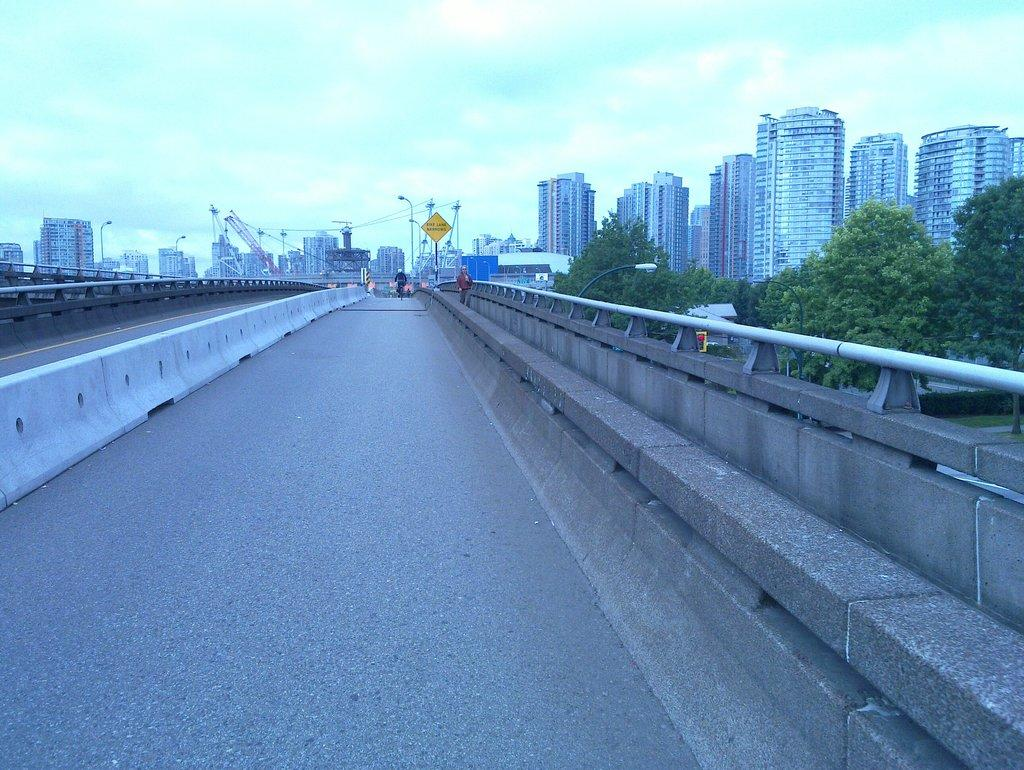What is the main feature of the image? The image contains a road. What can be seen on the right side of the image? There are trees and buildings on the right side of the image. What type of pollution can be seen coming from the animal in the image? There is no animal present in the image, so there is no pollution to be seen. 